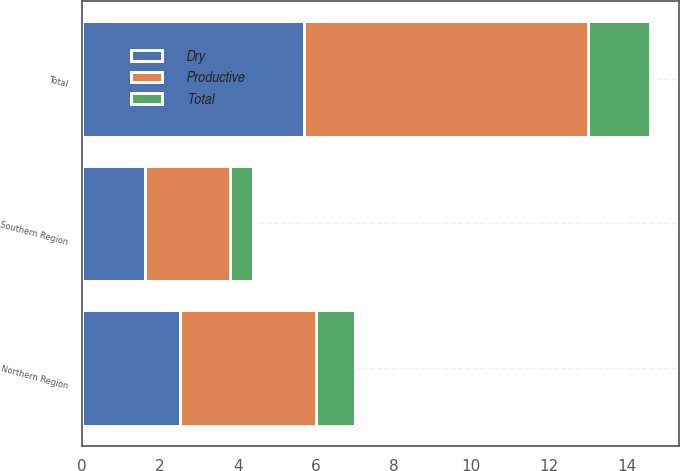Convert chart. <chart><loc_0><loc_0><loc_500><loc_500><stacked_bar_chart><ecel><fcel>Northern Region<fcel>Southern Region<fcel>Total<nl><fcel>Dry<fcel>2.5<fcel>1.6<fcel>5.7<nl><fcel>Total<fcel>1<fcel>0.6<fcel>1.6<nl><fcel>Productive<fcel>3.5<fcel>2.2<fcel>7.3<nl></chart> 